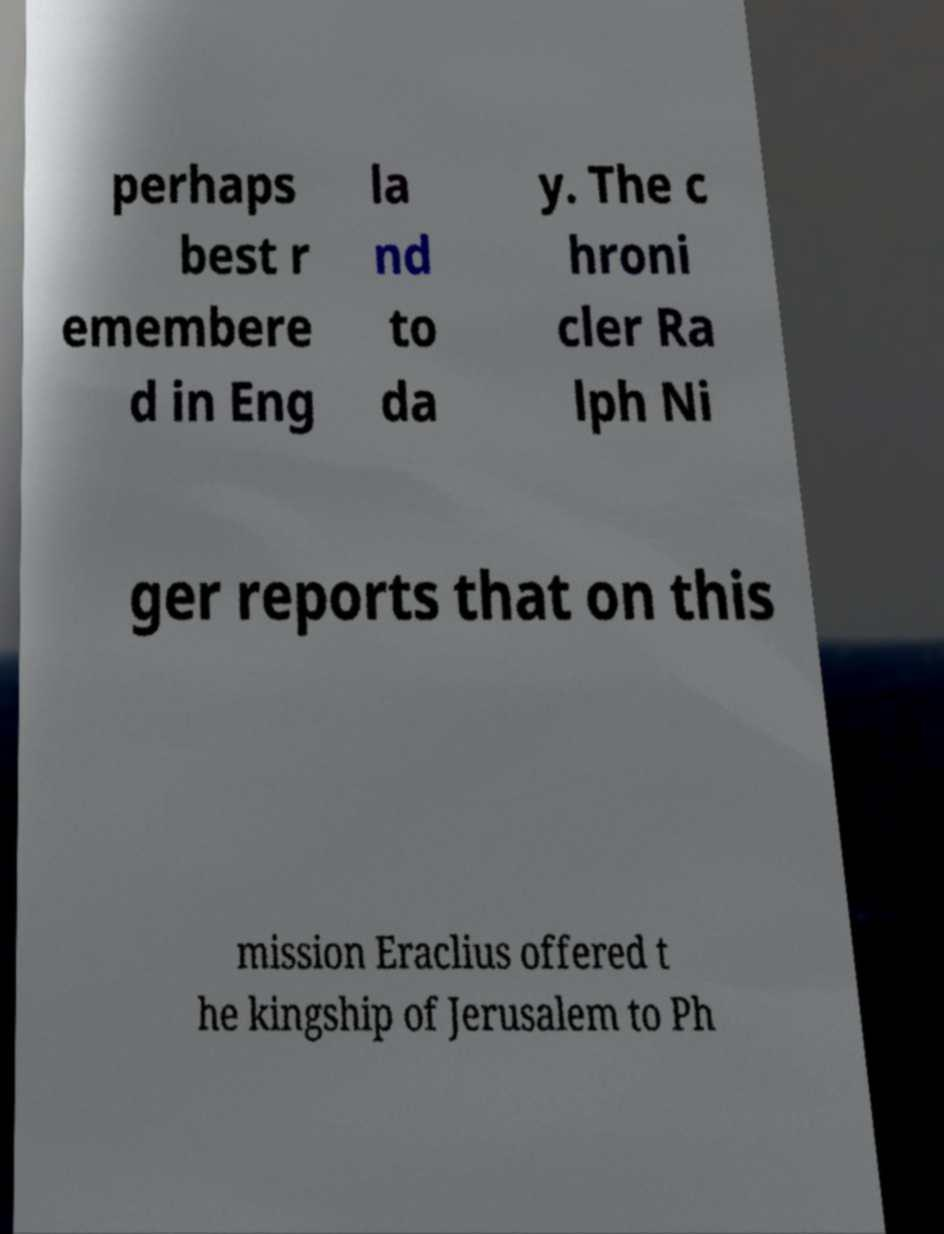I need the written content from this picture converted into text. Can you do that? perhaps best r emembere d in Eng la nd to da y. The c hroni cler Ra lph Ni ger reports that on this mission Eraclius offered t he kingship of Jerusalem to Ph 